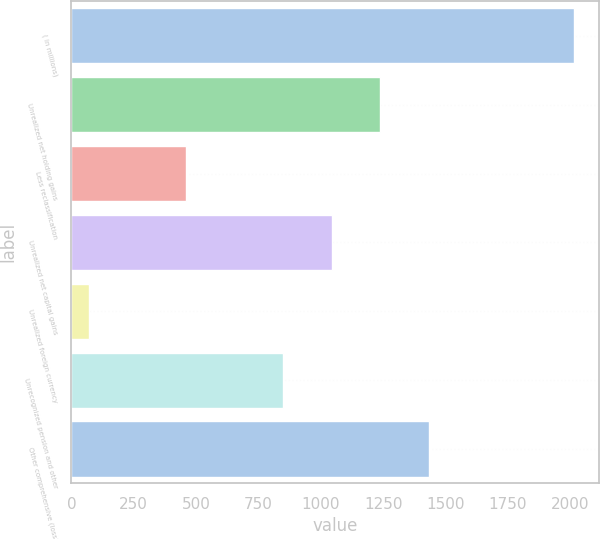<chart> <loc_0><loc_0><loc_500><loc_500><bar_chart><fcel>( in millions)<fcel>Unrealized net holding gains<fcel>Less reclassification<fcel>Unrealized net capital gains<fcel>Unrealized foreign currency<fcel>Unrecognized pension and other<fcel>Other comprehensive (loss)<nl><fcel>2017<fcel>1239<fcel>461<fcel>1044.5<fcel>72<fcel>850<fcel>1433.5<nl></chart> 